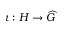<formula> <loc_0><loc_0><loc_500><loc_500>\iota \colon H \to { \widehat { G } }</formula> 